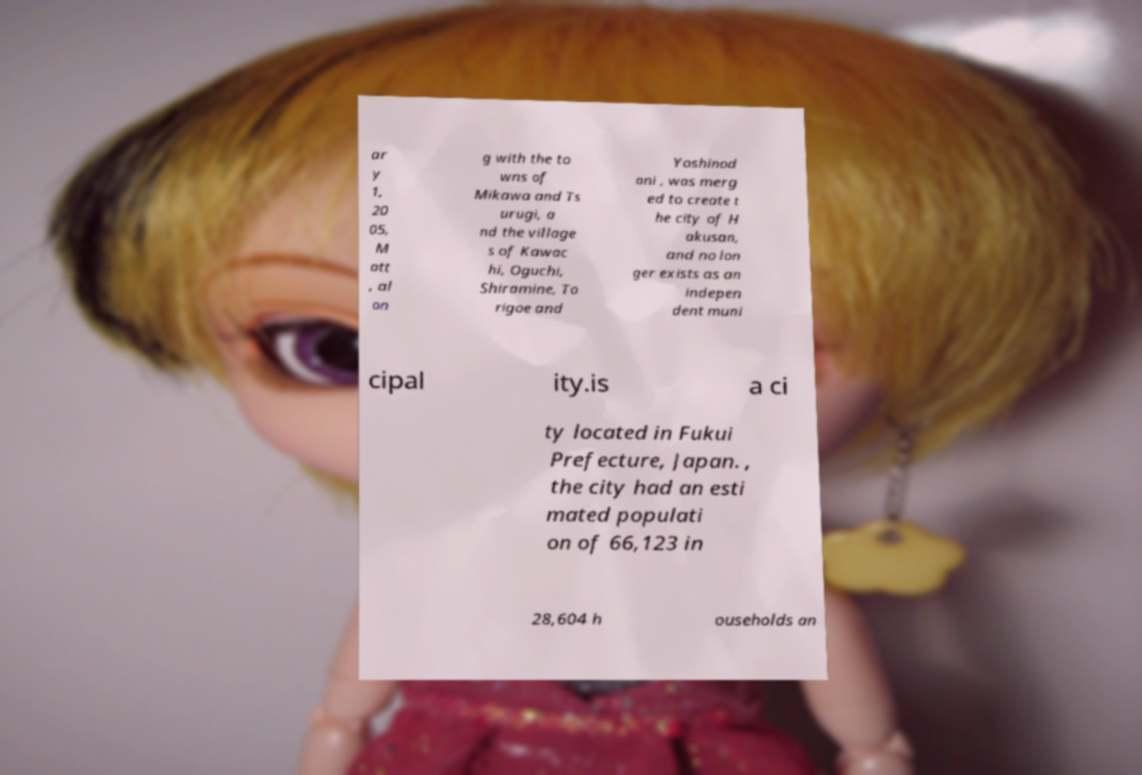Please read and relay the text visible in this image. What does it say? ar y 1, 20 05, M att , al on g with the to wns of Mikawa and Ts urugi, a nd the village s of Kawac hi, Oguchi, Shiramine, To rigoe and Yoshinod ani , was merg ed to create t he city of H akusan, and no lon ger exists as an indepen dent muni cipal ity.is a ci ty located in Fukui Prefecture, Japan. , the city had an esti mated populati on of 66,123 in 28,604 h ouseholds an 